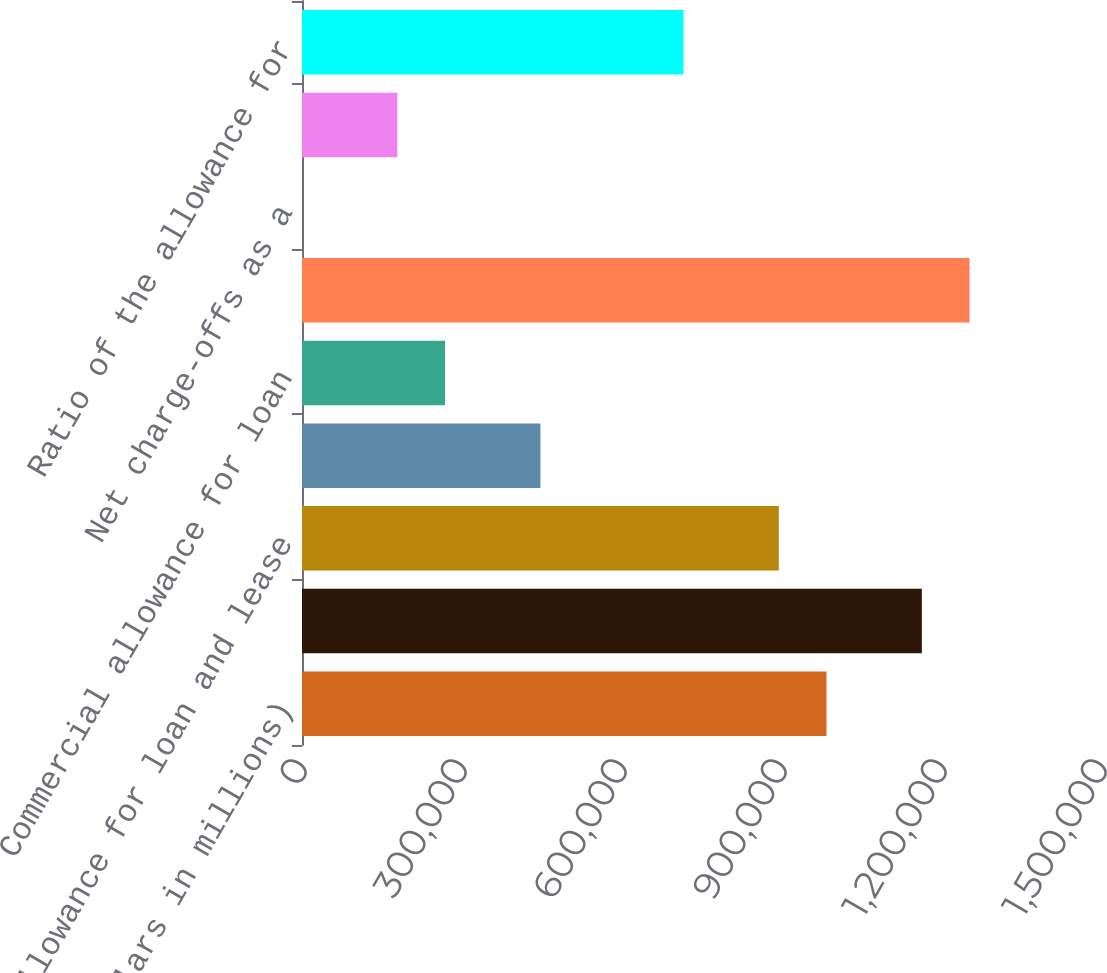<chart> <loc_0><loc_0><loc_500><loc_500><bar_chart><fcel>(Dollars in millions)<fcel>Loans and leases outstanding<fcel>Allowance for loan and lease<fcel>Consumer allowance for loan<fcel>Commercial allowance for loan<fcel>Average loans and leases<fcel>Net charge-offs as a<fcel>Net charge-offs and PCI<fcel>Ratio of the allowance for<nl><fcel>983401<fcel>1.1622e+06<fcel>894001<fcel>447001<fcel>268201<fcel>1.2516e+06<fcel>0.49<fcel>178801<fcel>715201<nl></chart> 